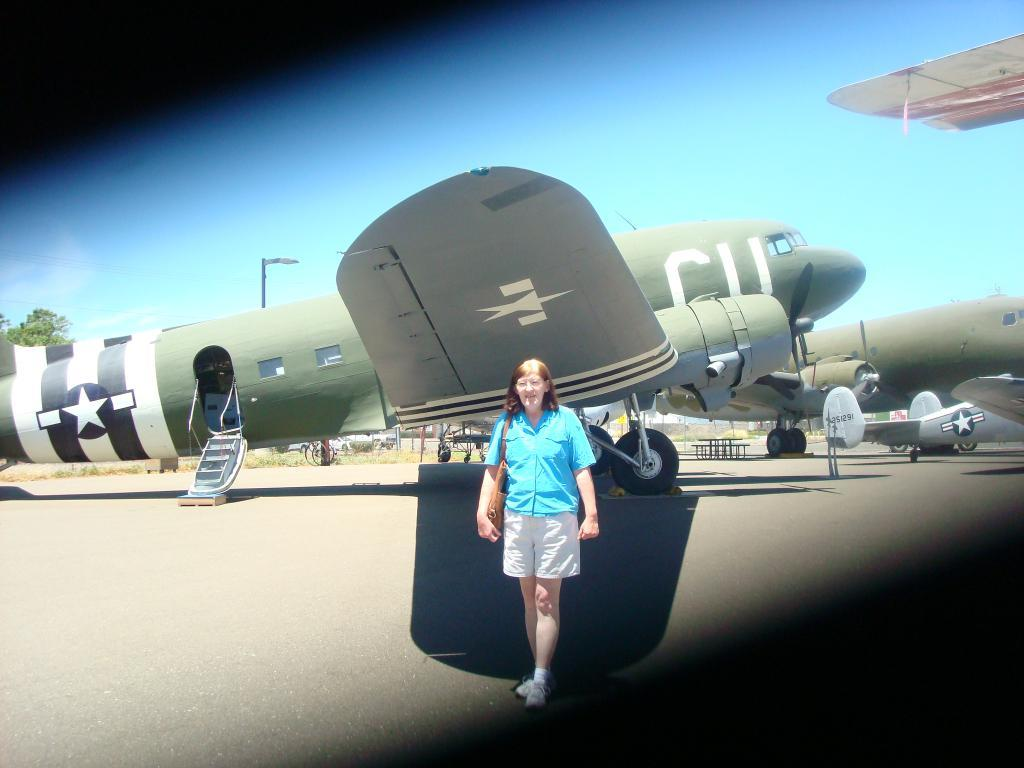<image>
Describe the image concisely. A woman stadning infront of an aeroplane with the letters CU on it 